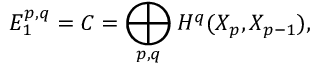Convert formula to latex. <formula><loc_0><loc_0><loc_500><loc_500>E _ { 1 } ^ { p , q } = C = \bigoplus _ { p , q } H ^ { q } ( X _ { p } , X _ { p - 1 } ) ,</formula> 